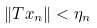<formula> <loc_0><loc_0><loc_500><loc_500>\| T x _ { n } \| < \eta _ { n }</formula> 